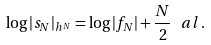Convert formula to latex. <formula><loc_0><loc_0><loc_500><loc_500>\log | s _ { N } | _ { h ^ { N } } = \log | f _ { N } | + \frac { N } { 2 } \, \ a l \, .</formula> 